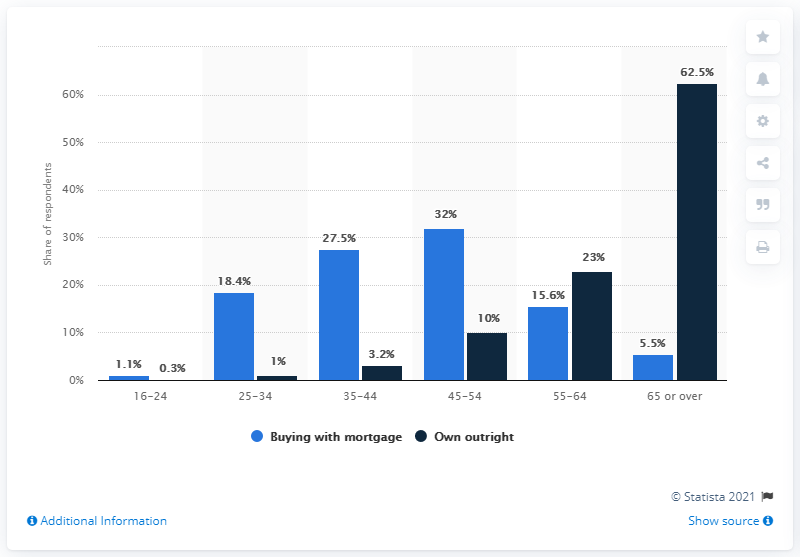Point out several critical features in this image. Approximately 0.3% of owner-occupier homeowners were between the ages of 16 and 24. 